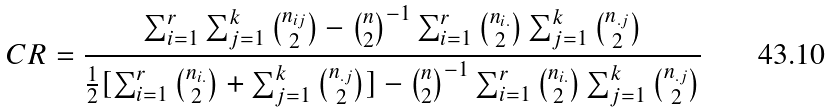<formula> <loc_0><loc_0><loc_500><loc_500>C R = \frac { \sum _ { i = 1 } ^ { r } \sum _ { j = 1 } ^ { k } { { n _ { i j } } \choose { 2 } } - { { n } \choose { 2 } } ^ { - 1 } \sum _ { i = 1 } ^ { r } { { n _ { i . } } \choose { 2 } } \sum _ { j = 1 } ^ { k } { { n _ { . j } } \choose { 2 } } } { \frac { 1 } { 2 } [ \sum _ { i = 1 } ^ { r } { { n _ { i . } } \choose { 2 } } + \sum _ { j = 1 } ^ { k } { { n _ { . j } } \choose { 2 } } ] - { { n } \choose { 2 } } ^ { - 1 } \sum _ { i = 1 } ^ { r } { { n _ { i . } } \choose { 2 } } \sum _ { j = 1 } ^ { k } { { n _ { . j } } \choose { 2 } } }</formula> 